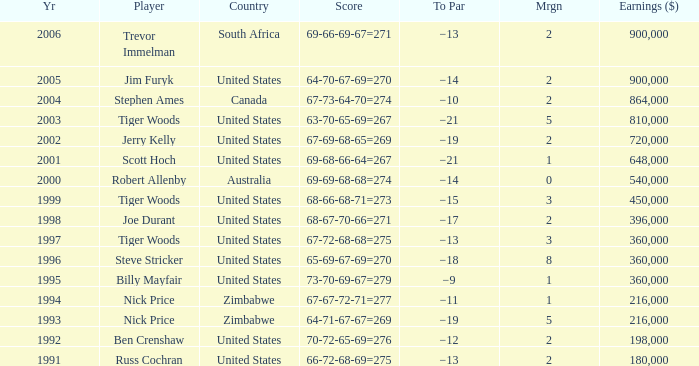What is canada's margin? 2.0. 